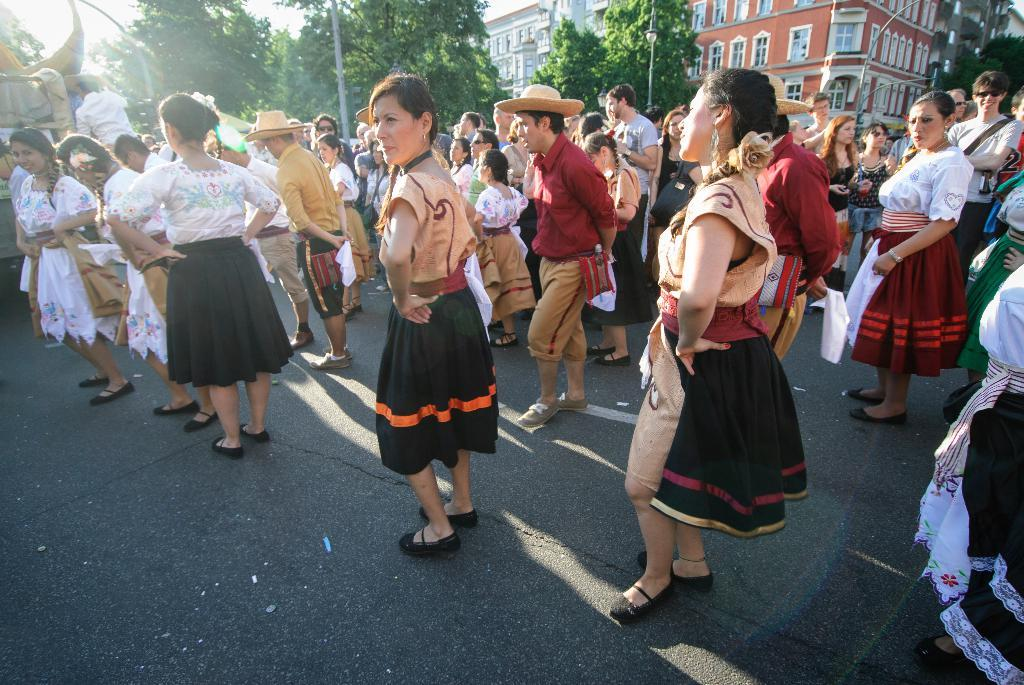What is happening on the road in the image? There are people on the road in the image. What structures can be seen in the image? There are poles and buildings visible in the image. What type of vegetation is present in the image? There are trees in the image. What else can be seen in the image besides the people and structures? There are objects in the image. What is visible in the background of the image? The sky is visible in the background of the image, along with the buildings. Where are the pigs located in the image? There are no pigs present in the image. Is there a baby visible in the image? There is no baby visible in the image. 